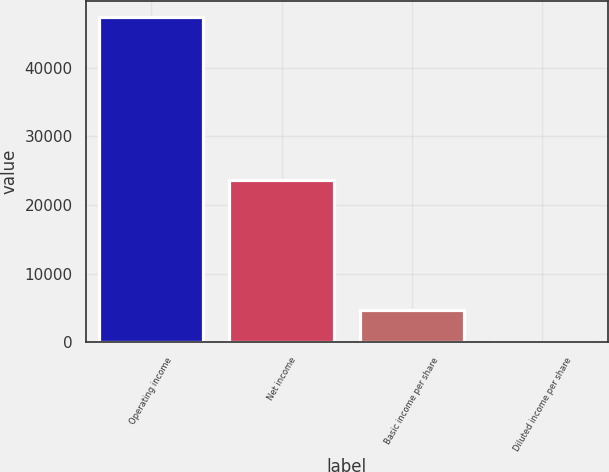<chart> <loc_0><loc_0><loc_500><loc_500><bar_chart><fcel>Operating income<fcel>Net income<fcel>Basic income per share<fcel>Diluted income per share<nl><fcel>47333<fcel>23589<fcel>4733.53<fcel>0.25<nl></chart> 